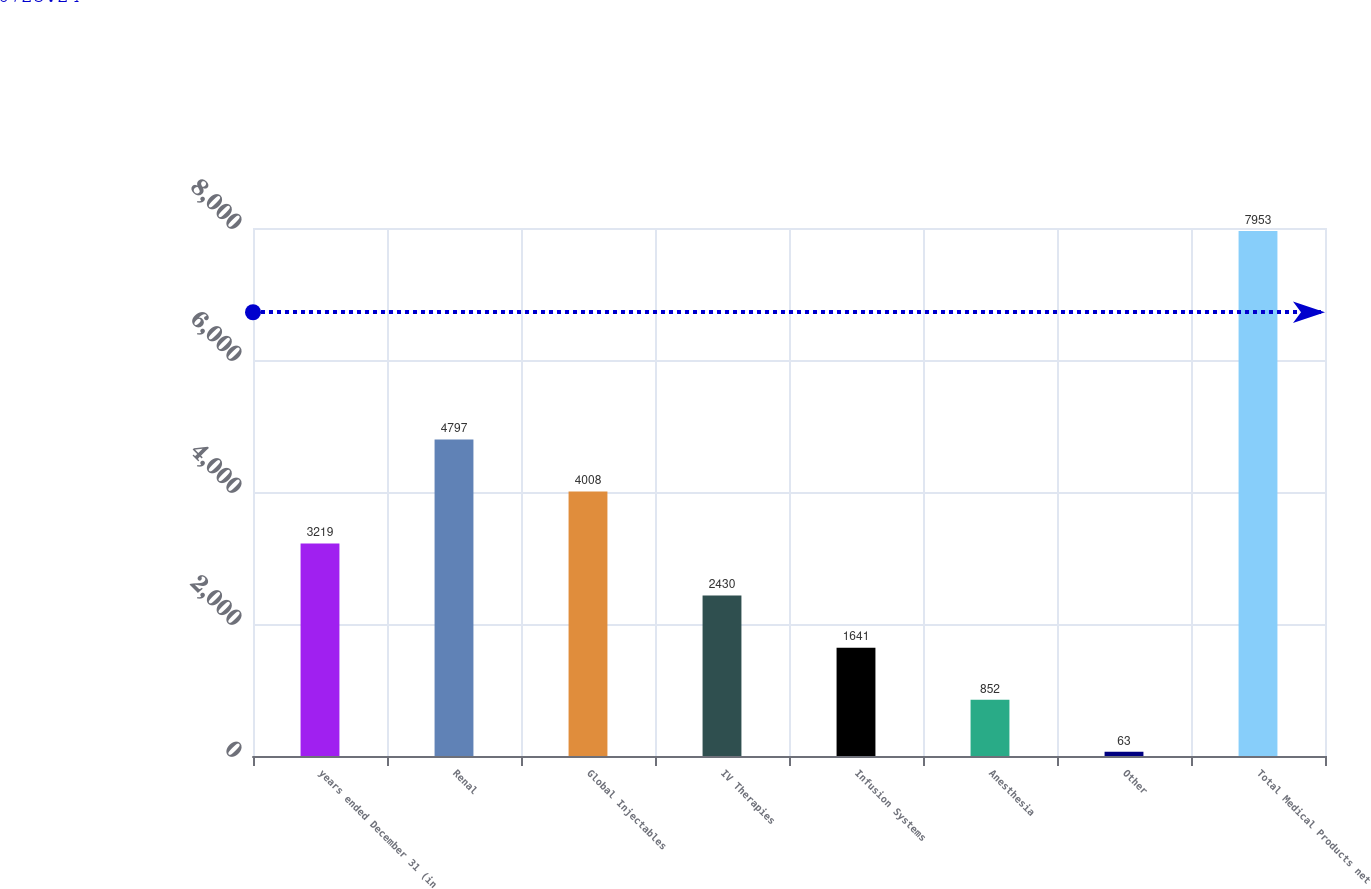Convert chart to OTSL. <chart><loc_0><loc_0><loc_500><loc_500><bar_chart><fcel>years ended December 31 (in<fcel>Renal<fcel>Global Injectables<fcel>IV Therapies<fcel>Infusion Systems<fcel>Anesthesia<fcel>Other<fcel>Total Medical Products net<nl><fcel>3219<fcel>4797<fcel>4008<fcel>2430<fcel>1641<fcel>852<fcel>63<fcel>7953<nl></chart> 